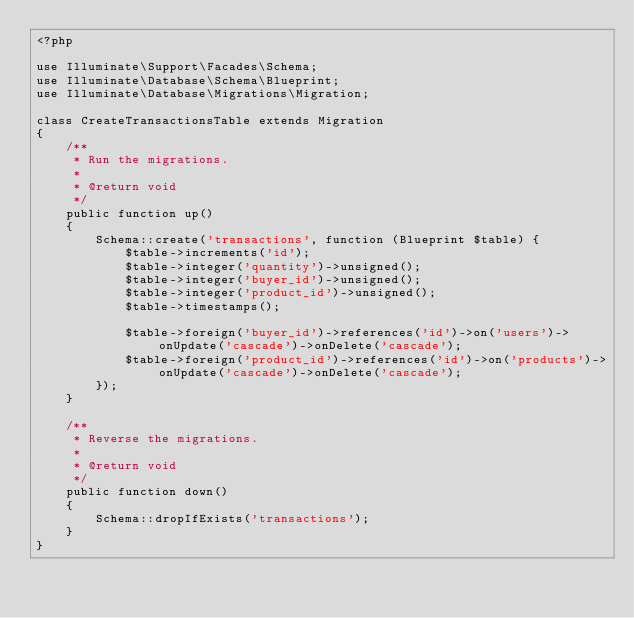Convert code to text. <code><loc_0><loc_0><loc_500><loc_500><_PHP_><?php

use Illuminate\Support\Facades\Schema;
use Illuminate\Database\Schema\Blueprint;
use Illuminate\Database\Migrations\Migration;

class CreateTransactionsTable extends Migration
{
    /**
     * Run the migrations.
     *
     * @return void
     */
    public function up()
    {
        Schema::create('transactions', function (Blueprint $table) {
            $table->increments('id');
            $table->integer('quantity')->unsigned();
            $table->integer('buyer_id')->unsigned();
            $table->integer('product_id')->unsigned();
            $table->timestamps();

            $table->foreign('buyer_id')->references('id')->on('users')->onUpdate('cascade')->onDelete('cascade');
            $table->foreign('product_id')->references('id')->on('products')->onUpdate('cascade')->onDelete('cascade');
        });
    }

    /**
     * Reverse the migrations.
     *
     * @return void
     */
    public function down()
    {
        Schema::dropIfExists('transactions');
    }
}
</code> 